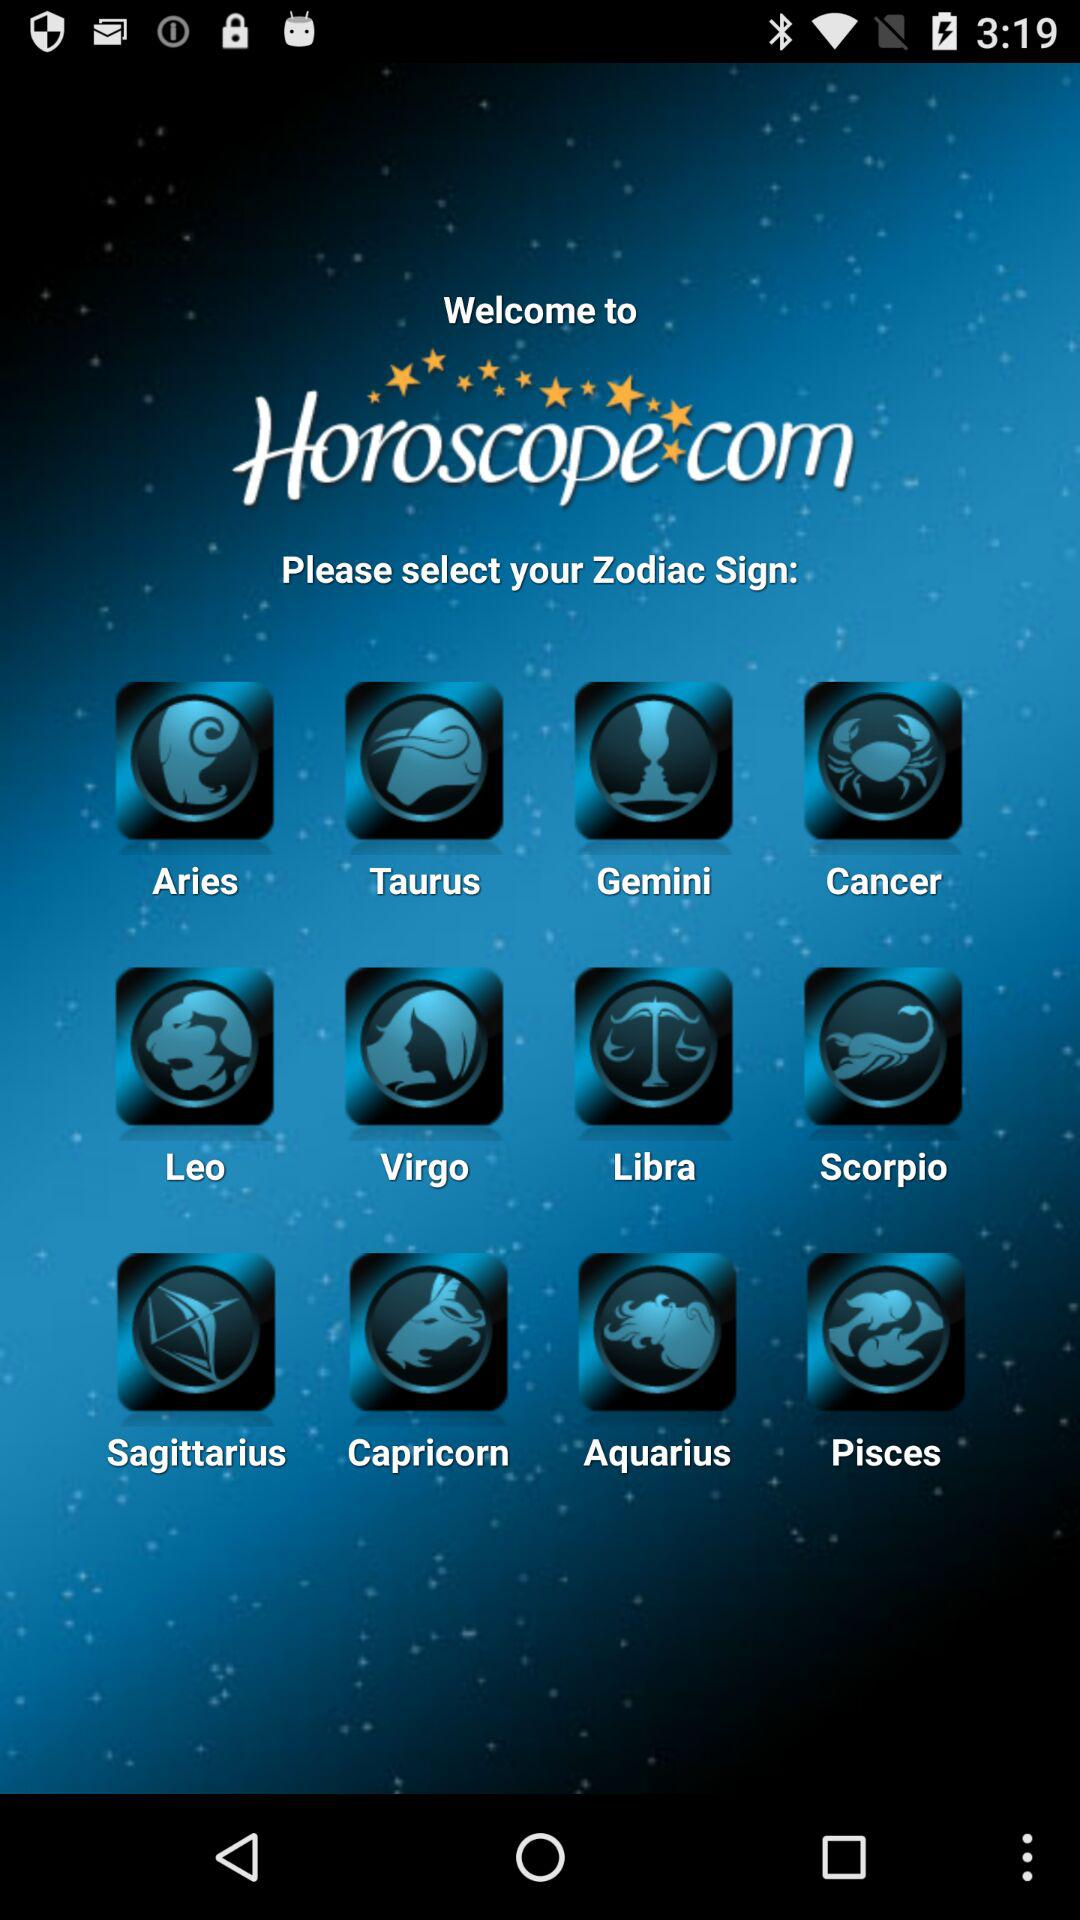What is the name of the developer? The name of the developer is "Horoscope.com". 